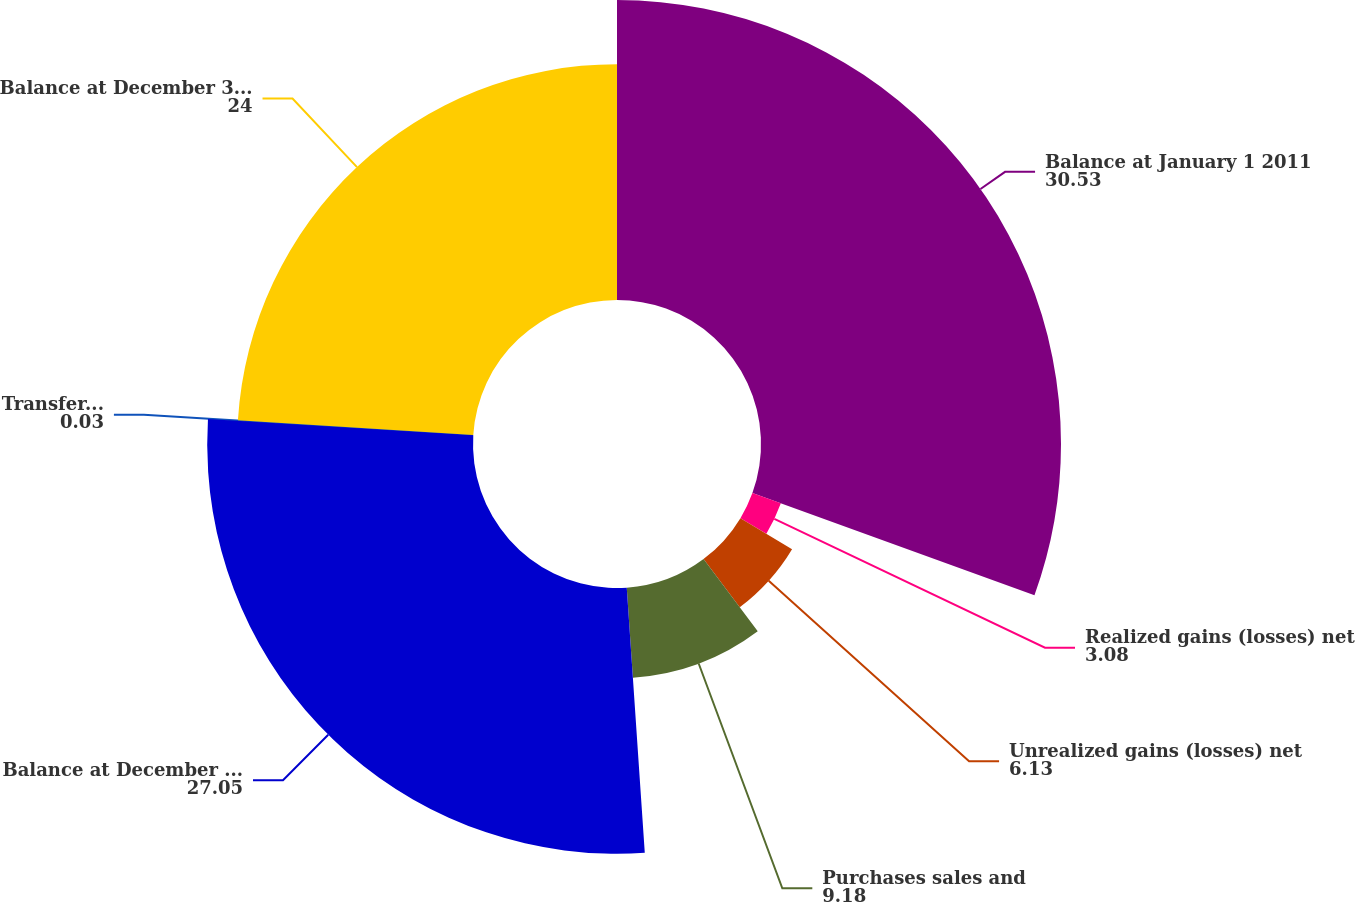Convert chart. <chart><loc_0><loc_0><loc_500><loc_500><pie_chart><fcel>Balance at January 1 2011<fcel>Realized gains (losses) net<fcel>Unrealized gains (losses) net<fcel>Purchases sales and<fcel>Balance at December 31 2011<fcel>Transfers into (out of) Level<fcel>Balance at December 31 2012<nl><fcel>30.53%<fcel>3.08%<fcel>6.13%<fcel>9.18%<fcel>27.05%<fcel>0.03%<fcel>24.0%<nl></chart> 